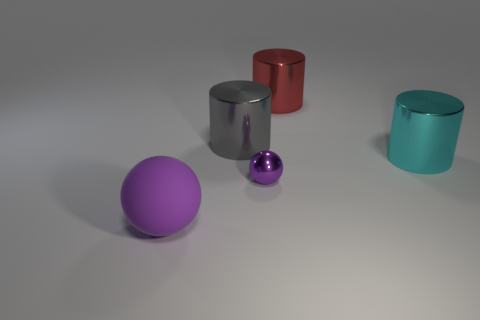Add 3 purple metallic things. How many objects exist? 8 Subtract all balls. How many objects are left? 3 Add 1 tiny blue matte cylinders. How many tiny blue matte cylinders exist? 1 Subtract 0 green spheres. How many objects are left? 5 Subtract all purple rubber blocks. Subtract all big metallic cylinders. How many objects are left? 2 Add 3 small objects. How many small objects are left? 4 